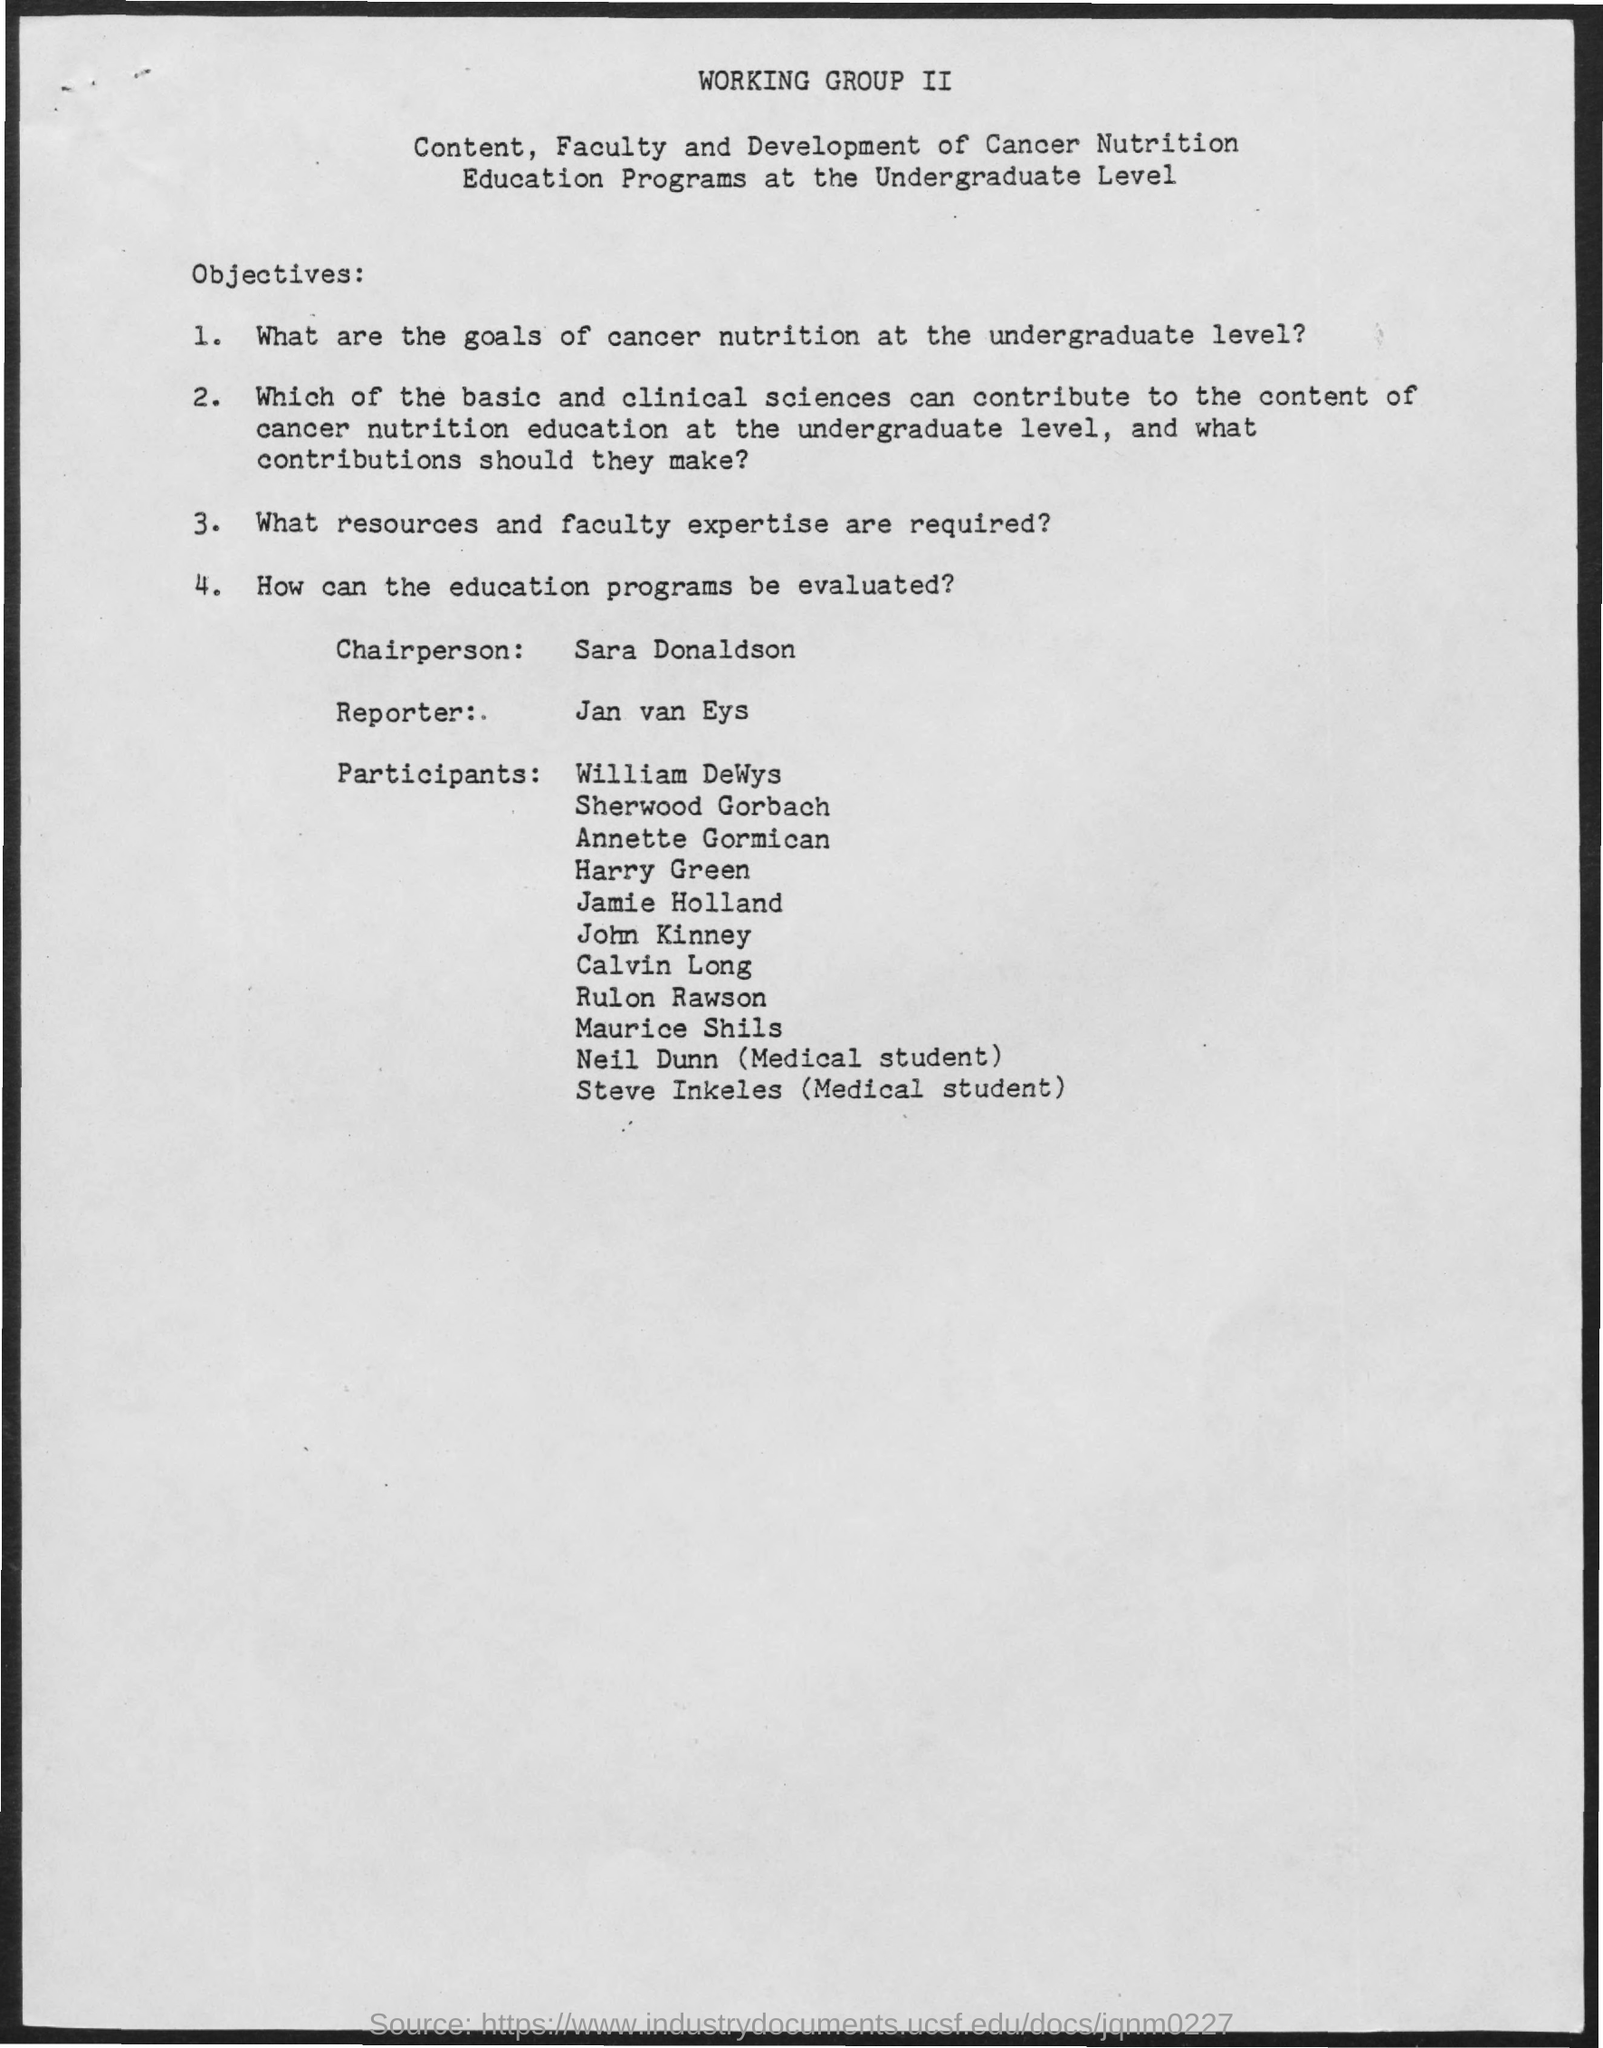Highlight a few significant elements in this photo. The Chairperson's name is Sara Donaldson. The reporter is Jan van Eys. 